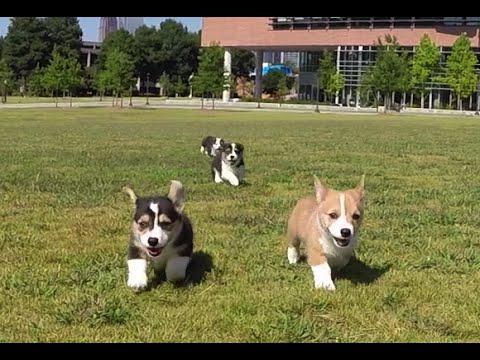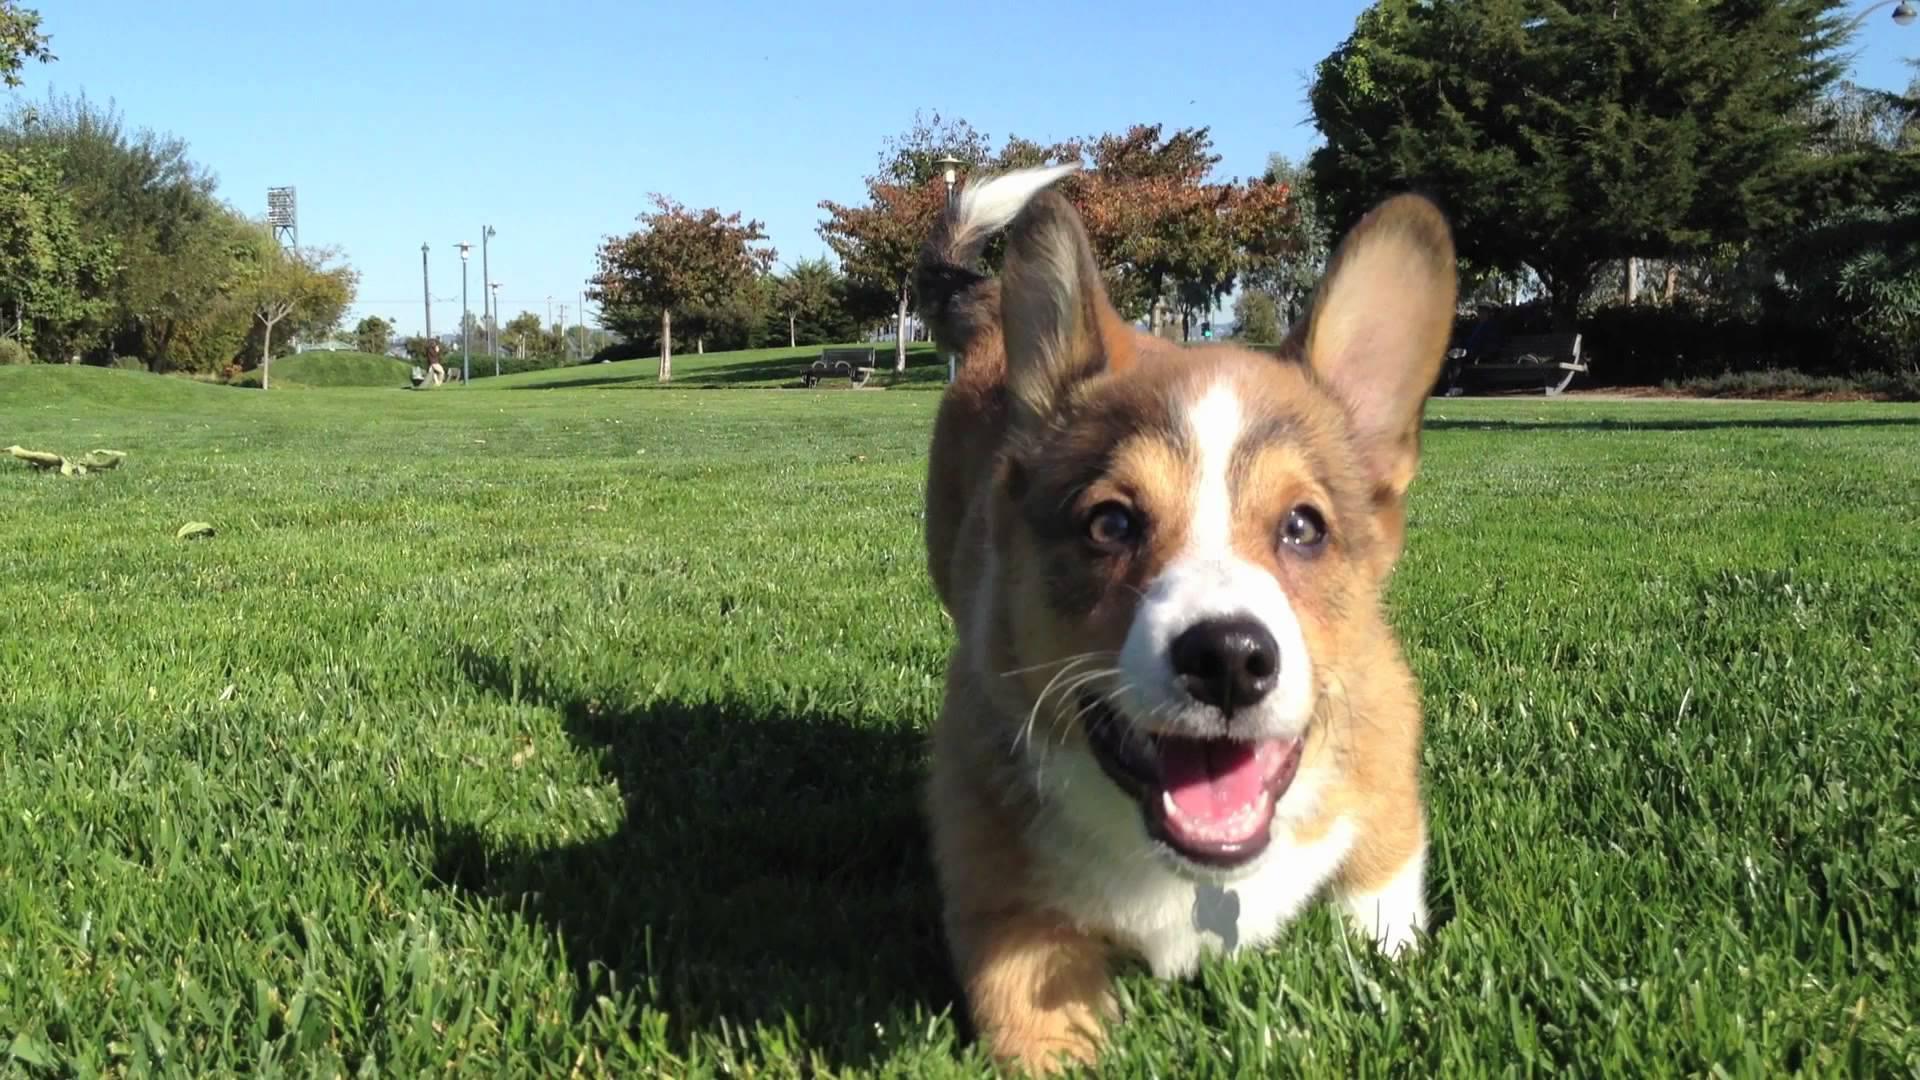The first image is the image on the left, the second image is the image on the right. Examine the images to the left and right. Is the description "At least one puppy has both front paws off the ground." accurate? Answer yes or no. No. The first image is the image on the left, the second image is the image on the right. Analyze the images presented: Is the assertion "One image shows three corgi dogs running across the grass, with one dog in the lead, and a blue tent canopy behind them." valid? Answer yes or no. No. 